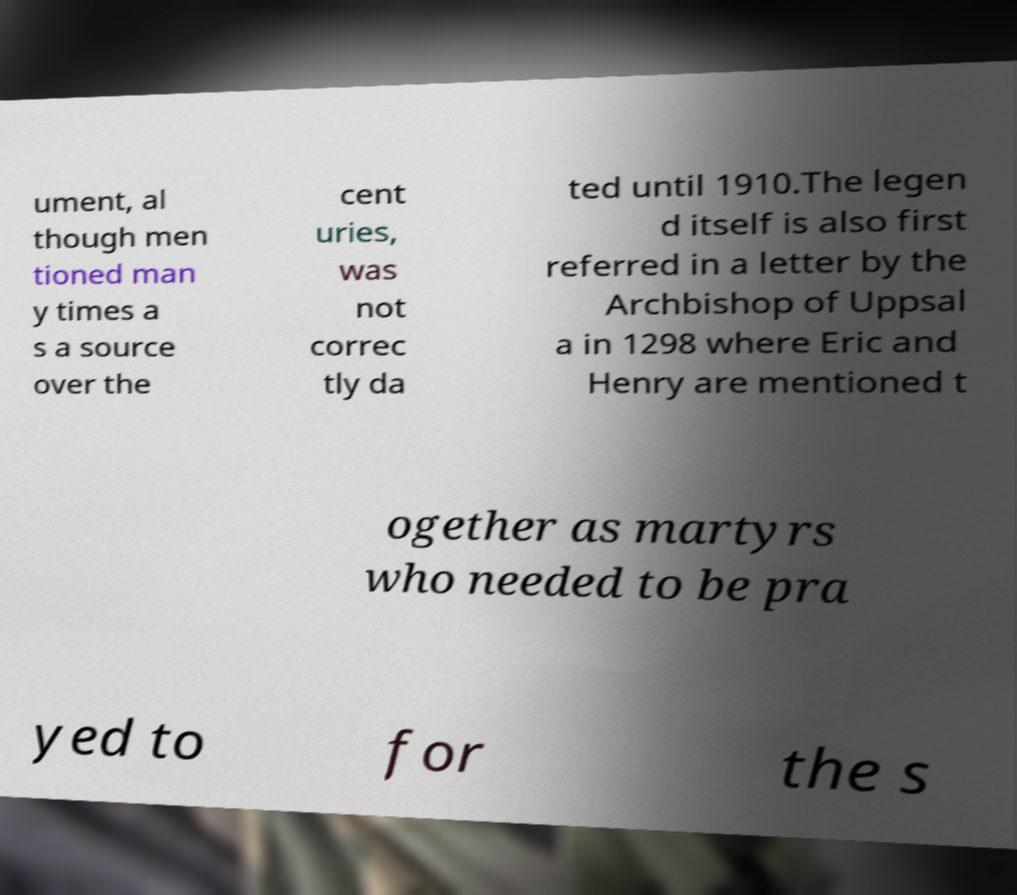Could you extract and type out the text from this image? ument, al though men tioned man y times a s a source over the cent uries, was not correc tly da ted until 1910.The legen d itself is also first referred in a letter by the Archbishop of Uppsal a in 1298 where Eric and Henry are mentioned t ogether as martyrs who needed to be pra yed to for the s 